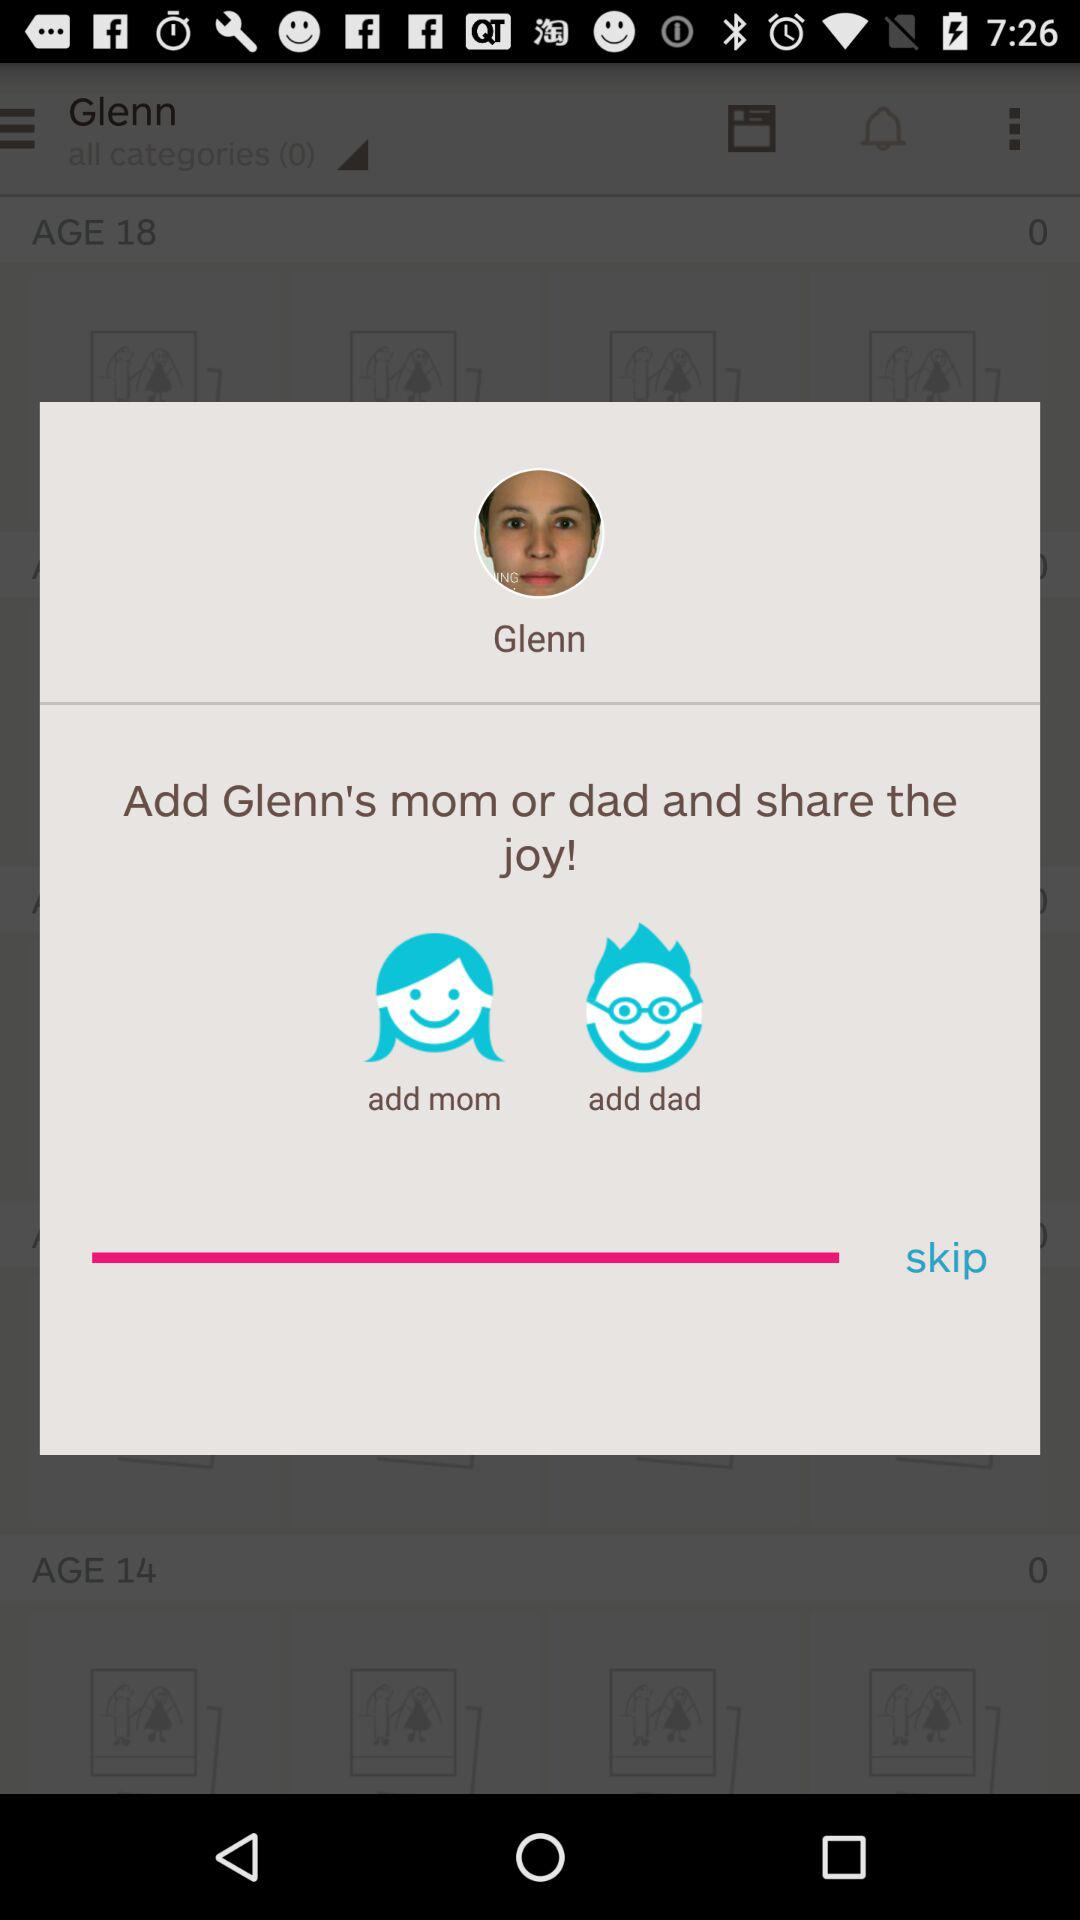What do we need to add to share the joy? You need to add Glenn's mom or dad to share the joy. 